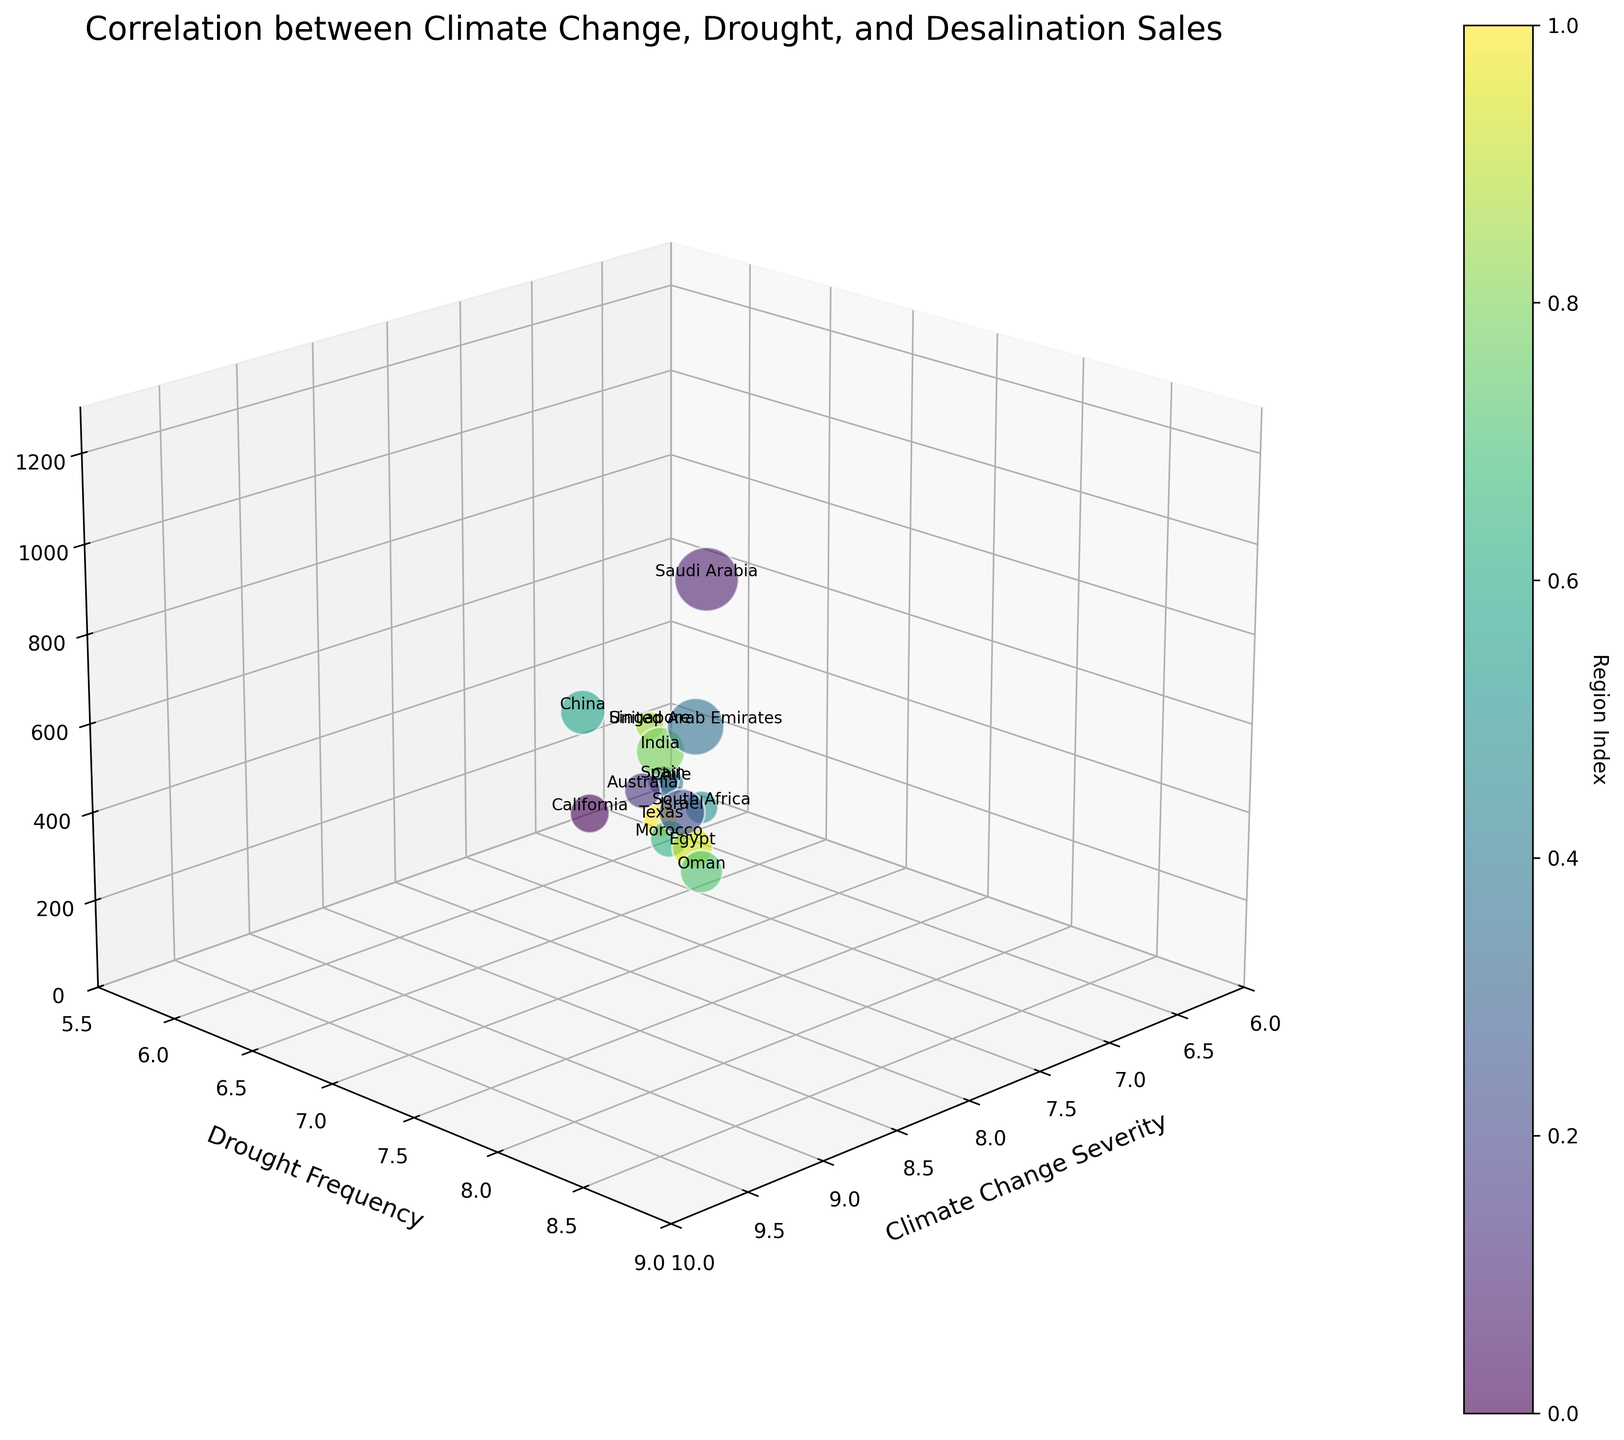How many regions are represented in the chart? Count the number of different regions labeled in the chart.
Answer: 15 What is the title of the chart? Look at the top part of the chart where the title is usually placed.
Answer: Correlation between Climate Change, Drought, and Desalination Sales Which axis represents drought frequency? Identify the label for the axis that reads "Drought Frequency".
Answer: Y-axis Which region has the highest desalination equipment sales? Find the bubble with the greatest z-coordinate (height) and identify the corresponding region label.
Answer: Saudi Arabia Which region exhibits the lowest climate change severity? Look at the x-axis values and locate the smallest x-coordinate; find the corresponding region.
Answer: Singapore What are the maximum values for each axis on the chart? Check the upper limits of the x, y, and z axes to find the maximum values.
Answer: 10 for Climate Change Severity, 9 for Drought Frequency, 1300 Million USD for Desalination Equipment Sales Which regions have desalination equipment sales greater than 500 million USD? Identify the bubbles with z-coordinates greater than 500 and read their labels.
Answer: Saudi Arabia, Israel, United Arab Emirates, India, China What is the average drought frequency of regions with climate change severity higher than 8? Identify the regions with climate change severity higher than 8, sum their drought frequencies, and divide by the number of such regions. (Saudi Arabia: 8.5, Israel: 8.1, United Arab Emirates: 8.7, Oman: 8.3, Egypt: 7.9, India: 7.8, China: 6.8, Morocco: 7.5, California: 7.2, Total: 61.8) Divide by the number of regions (10).
Answer: 7.725 Which region has both a high drought frequency and medium desalination equipment sales? Look for a bubble with high y-coordinate (close to 9) and mid-range z-coordinate (around 300-700); identify the corresponding region.
Answer: Morocco What is the combined desalination equipment sales of Saudi Arabia and the United Arab Emirates? Sum the desalination equipment sales values of Saudi Arabia and the United Arab Emirates (1200 + 950).
Answer: 2150 Million USD 